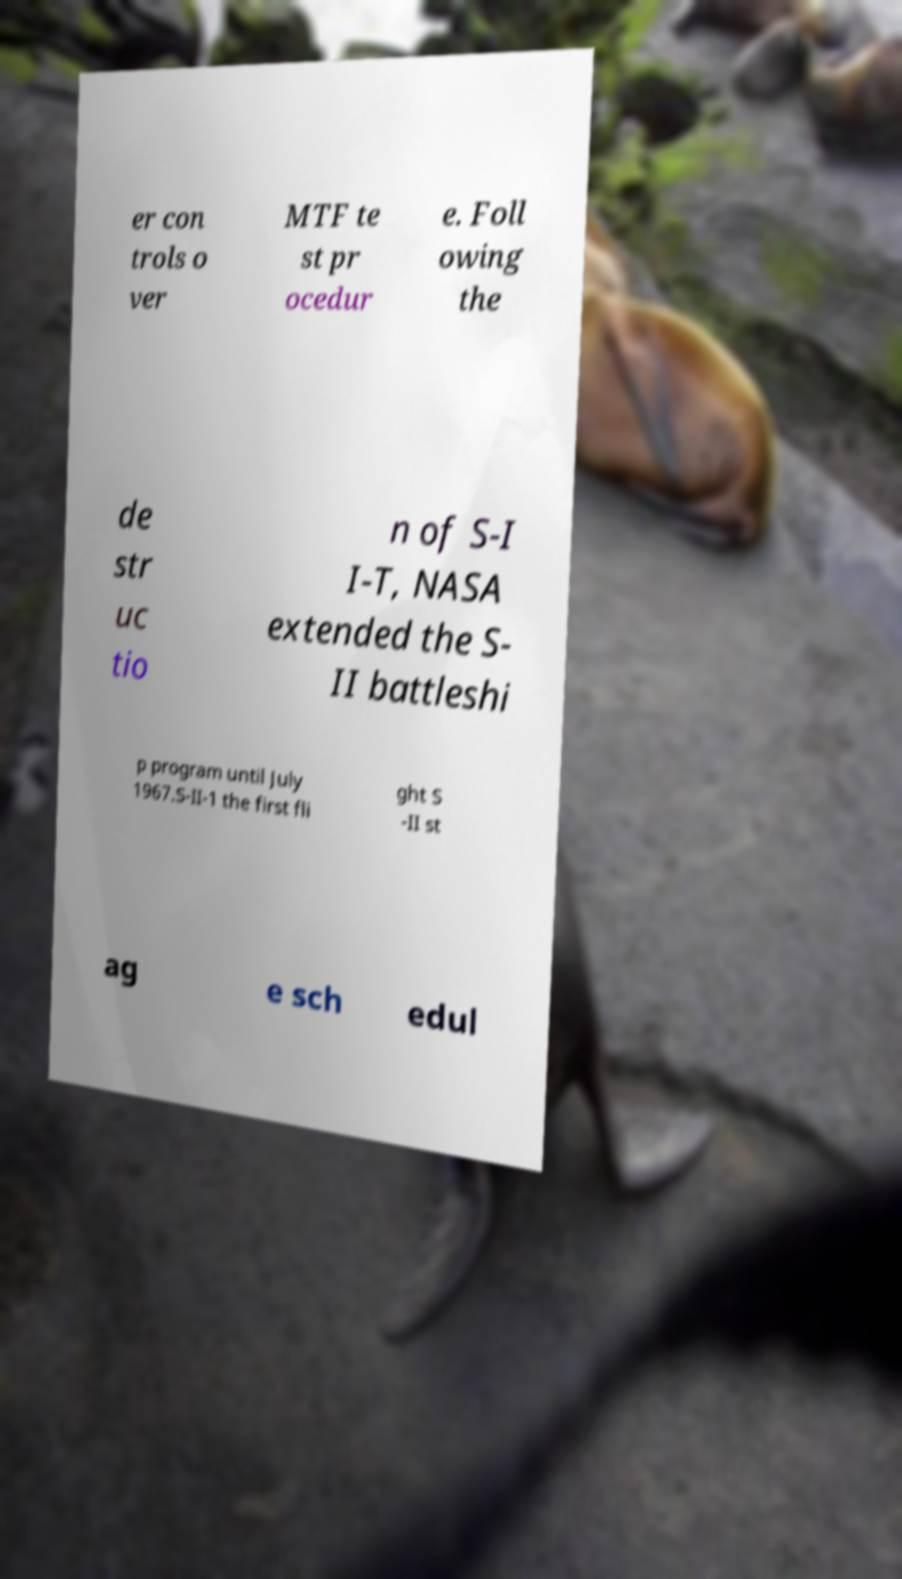Please read and relay the text visible in this image. What does it say? er con trols o ver MTF te st pr ocedur e. Foll owing the de str uc tio n of S-I I-T, NASA extended the S- II battleshi p program until July 1967.S-II-1 the first fli ght S -II st ag e sch edul 